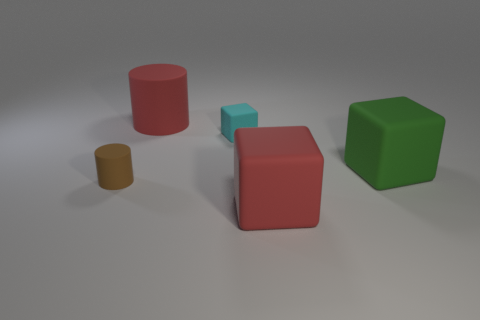Are the shadows in the image consistent with one another? Yes, the shadows in the image are consistent and indicate a single light source from above the scene, slightly to the right. Each object casts a shadow that aligns with the direction of the light source, creating a realistic portrayal of how light interacts with objects in a space. 